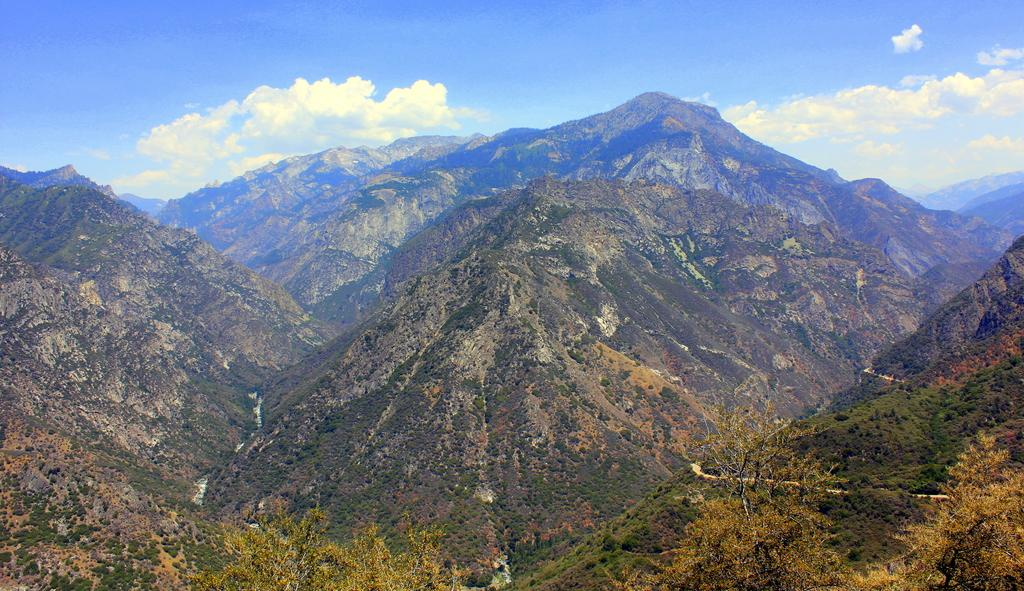What type of natural features can be seen in the image? There are trees and mountains in the image. What is visible in the sky at the top of the image? There are clouds in the sky at the top of the image. What type of wine is being served on the mountain in the image? There is no wine or indication of a gathering in the image; it features trees, mountains, and clouds. 